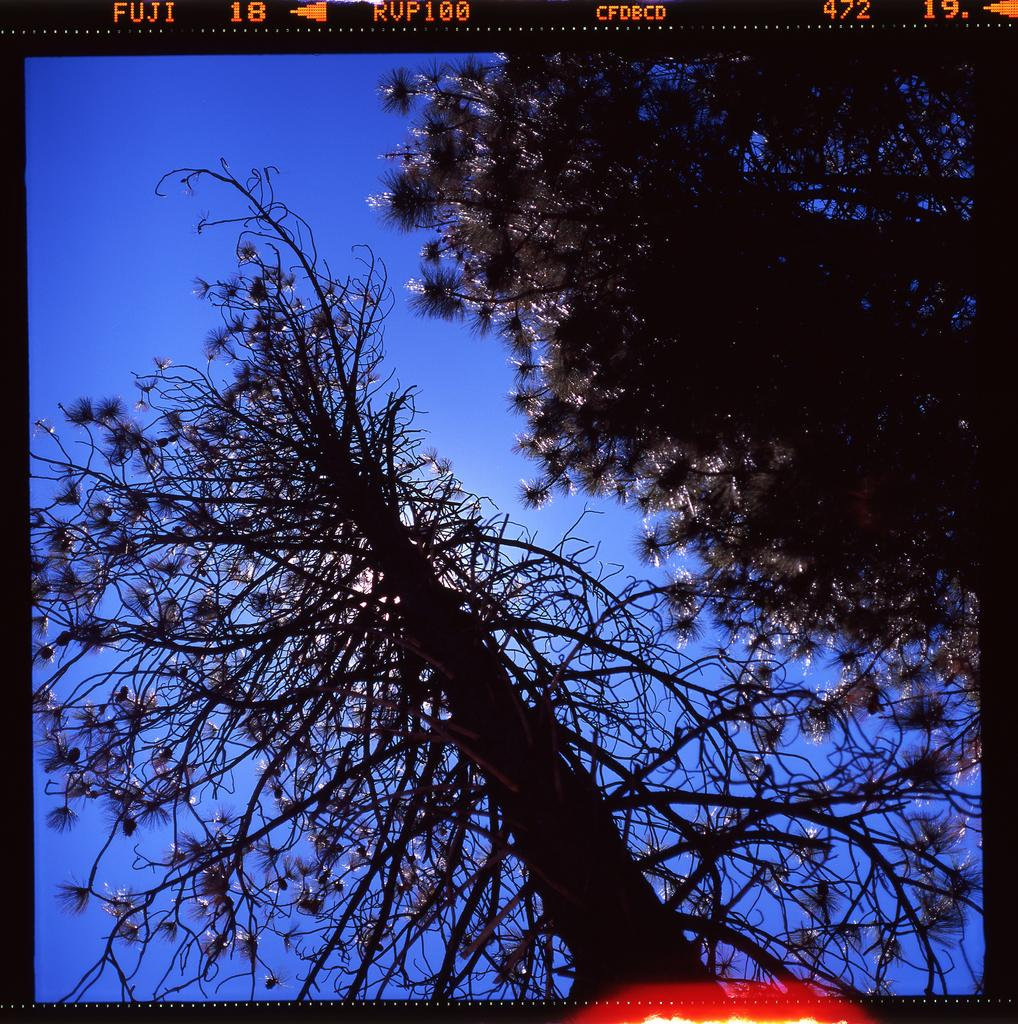What type of vegetation can be seen in the image? There are trees in the image. What part of the natural environment is visible in the image? The sky is visible in the background of the image. What type of fowl can be seen in the stomach of the person in the image? There is no person or stomach present in the image; it only features trees and the sky. 